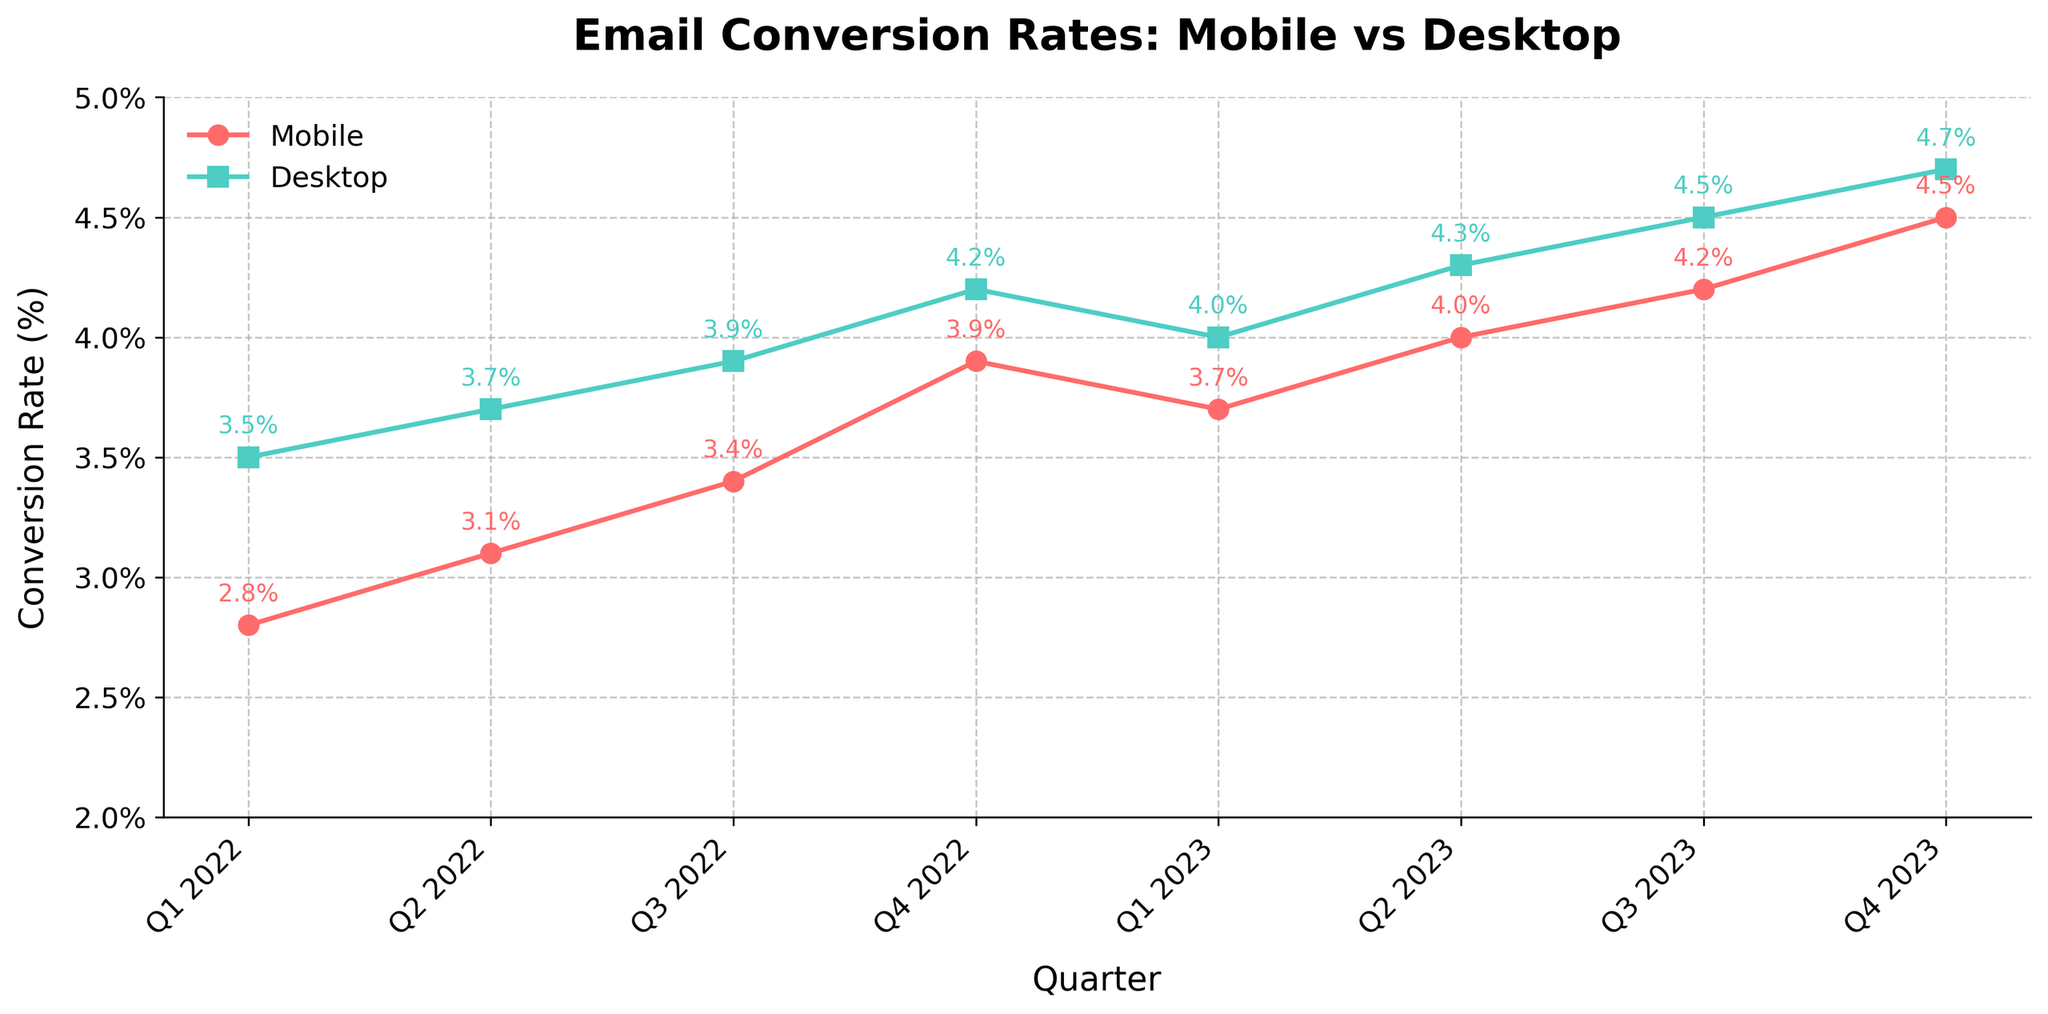what is the overall trend for mobile conversion rates from Q1 2022 to Q4 2023? From Q1 2022 to Q4 2023, the mobile conversion rates exhibit an overall increasing trend, starting at 2.8% in Q1 2022 and rising to 4.5% by Q4 2023.
Answer: Increasing During which quarter is the difference between mobile and desktop conversion rates the smallest? The smallest difference between mobile and desktop conversion rates occurs in Q3 2023, where the rates are 4.2% for mobile and 4.5% for desktop, resulting in a difference of only 0.3%.
Answer: Q3 2023 What is the average desktop conversion rate across all the quarters? First, convert the percentages to their decimal form and sum them: 3.5 + 3.7 + 3.9 + 4.2 + 4.0 + 4.3 + 4.5 + 4.7, which equals 33.8. Then, divide by the number of data points (8) to find the average: 33.8 ÷ 8 = 4.225%.
Answer: 4.2% Which quarter shows the highest mobile conversion rate? The highest mobile conversion rate is in Q4 2023, where the rate is 4.5%.
Answer: Q4 2023 How does the rate of increase from Q1 2022 to Q2 2022 for mobile compare to desktop? For mobile, the increase from Q1 2022 (2.8%) to Q2 2022 (3.1%) is 0.3%. For desktop, the increase from Q1 2022 (3.5%) to Q2 2022 (3.7%) is 0.2%. Therefore, the mobile increase is slightly higher than the desktop increase during this period.
Answer: Mobile increase is higher Does any quarter show a decline in desktop conversion rates? Yes, a decline is seen from Q4 2022 (4.2%) to Q1 2023 (4.0%).
Answer: Yes Which line (mobile or desktop) has more frequent fluctuations? Both the mobile and desktop lines show relatively stable and consistent upward trends, but the mobile line has a slight dip in Q1 2023, whereas the desktop line shows a more gradual increase with fewer fluctuations.
Answer: Mobile What's the cumulative increase in mobile conversion rates from Q1 2022 to Q4 2023? Starting at 2.8% in Q1 2022 and ending at 4.5% in Q4 2023, the cumulative increase is 4.5% - 2.8% = 1.7%.
Answer: 1.7% Between Q2 2023 and Q3 2023, was the increase in mobile conversion rates higher than that of desktop? From Q2 2023 to Q3 2023, the mobile rate increased from 4.0% to 4.2% (an increase of 0.2%), while the desktop rate increased from 4.3% to 4.5% (an increase of 0.2%). Therefore, the increases were equal.
Answer: No, they are equal What is the ratio of mobile conversion rate to desktop conversion rate in Q4 2023? In Q4 2023, the mobile conversion rate is 4.5% and the desktop conversion rate is 4.7%. The ratio is 4.5/4.7 ≈ 0.957.
Answer: 0.957 